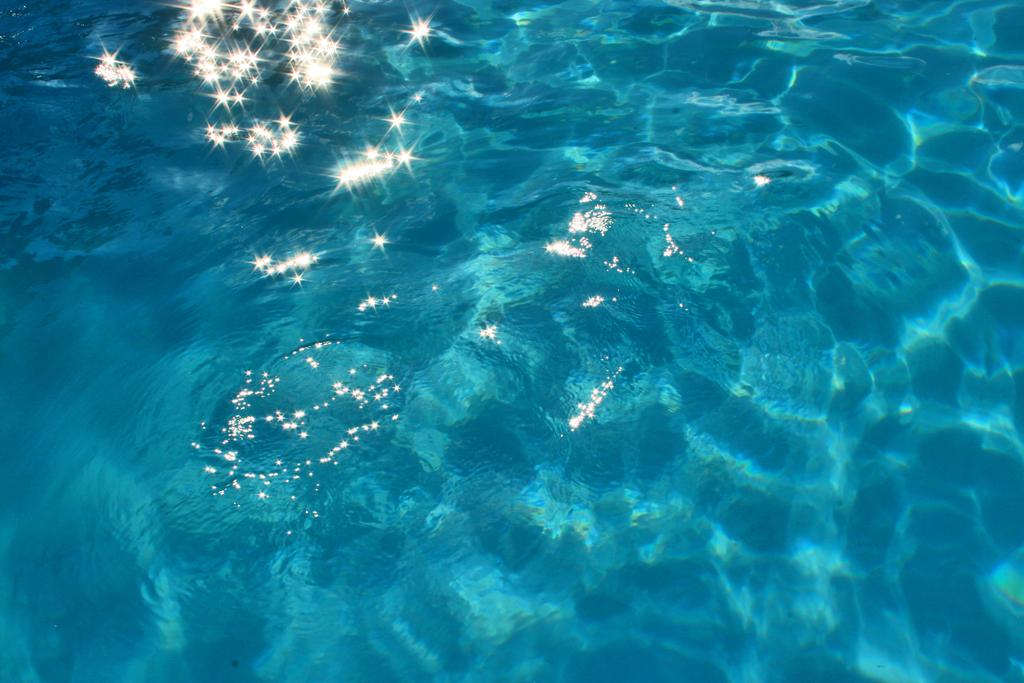What is the primary element visible in the image? There is water in the image. What additional feature can be seen in the image? There are white sparks visible in the image. Where is the frog sitting while reading a book in the image? There is no frog or book present in the image; it only features water and white sparks. 